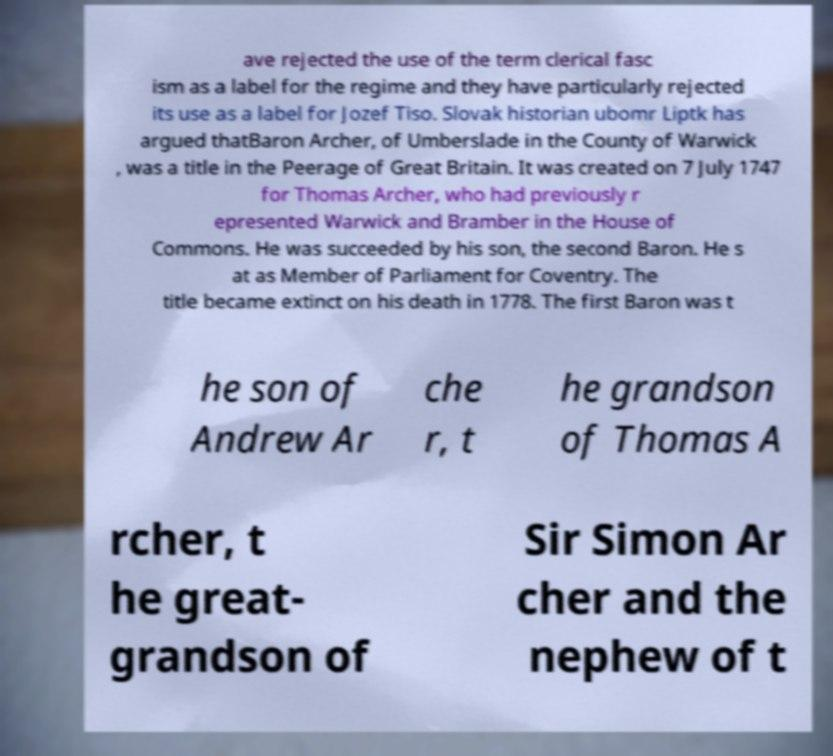Please identify and transcribe the text found in this image. ave rejected the use of the term clerical fasc ism as a label for the regime and they have particularly rejected its use as a label for Jozef Tiso. Slovak historian ubomr Liptk has argued thatBaron Archer, of Umberslade in the County of Warwick , was a title in the Peerage of Great Britain. It was created on 7 July 1747 for Thomas Archer, who had previously r epresented Warwick and Bramber in the House of Commons. He was succeeded by his son, the second Baron. He s at as Member of Parliament for Coventry. The title became extinct on his death in 1778. The first Baron was t he son of Andrew Ar che r, t he grandson of Thomas A rcher, t he great- grandson of Sir Simon Ar cher and the nephew of t 